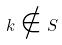Convert formula to latex. <formula><loc_0><loc_0><loc_500><loc_500>k \notin S</formula> 